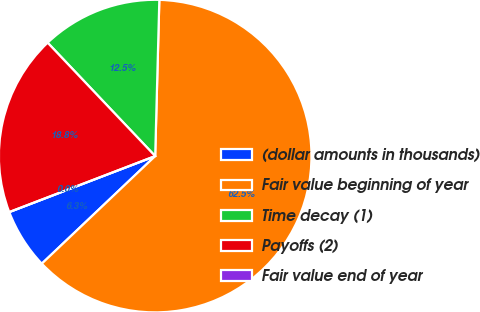Convert chart to OTSL. <chart><loc_0><loc_0><loc_500><loc_500><pie_chart><fcel>(dollar amounts in thousands)<fcel>Fair value beginning of year<fcel>Time decay (1)<fcel>Payoffs (2)<fcel>Fair value end of year<nl><fcel>6.25%<fcel>62.49%<fcel>12.5%<fcel>18.75%<fcel>0.0%<nl></chart> 